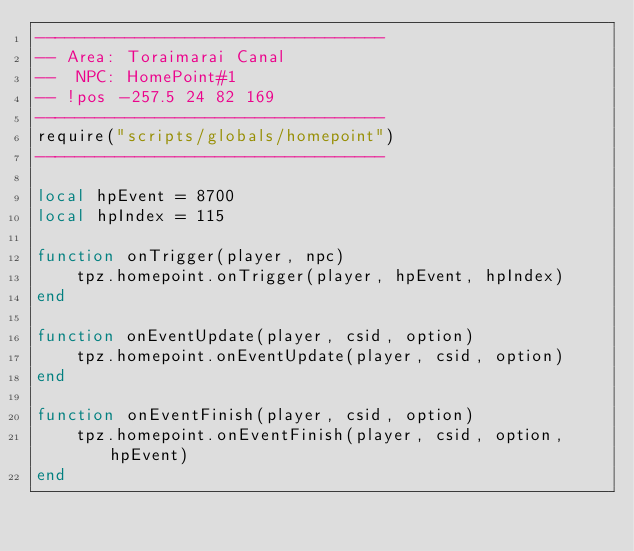<code> <loc_0><loc_0><loc_500><loc_500><_Lua_>-----------------------------------
-- Area: Toraimarai Canal
--  NPC: HomePoint#1
-- !pos -257.5 24 82 169
-----------------------------------
require("scripts/globals/homepoint")
-----------------------------------

local hpEvent = 8700
local hpIndex = 115

function onTrigger(player, npc)
    tpz.homepoint.onTrigger(player, hpEvent, hpIndex)
end

function onEventUpdate(player, csid, option)
    tpz.homepoint.onEventUpdate(player, csid, option)
end

function onEventFinish(player, csid, option)
    tpz.homepoint.onEventFinish(player, csid, option, hpEvent)
end
</code> 